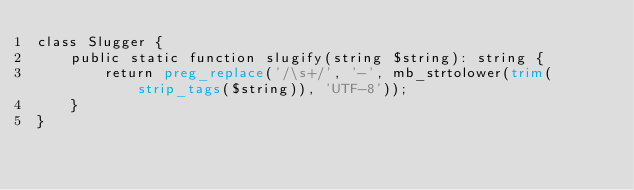<code> <loc_0><loc_0><loc_500><loc_500><_PHP_>class Slugger {
    public static function slugify(string $string): string {
        return preg_replace('/\s+/', '-', mb_strtolower(trim(strip_tags($string)), 'UTF-8'));
    }
}
</code> 